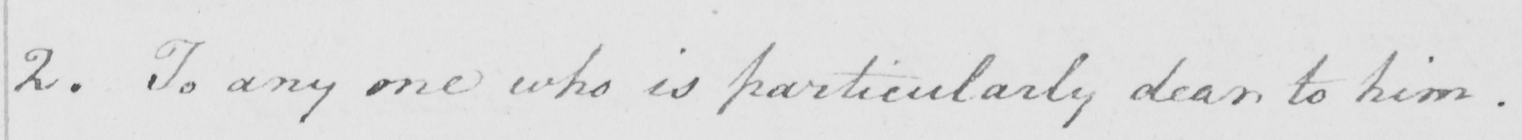Please provide the text content of this handwritten line. 2. To any one who is particularly dear to him. 